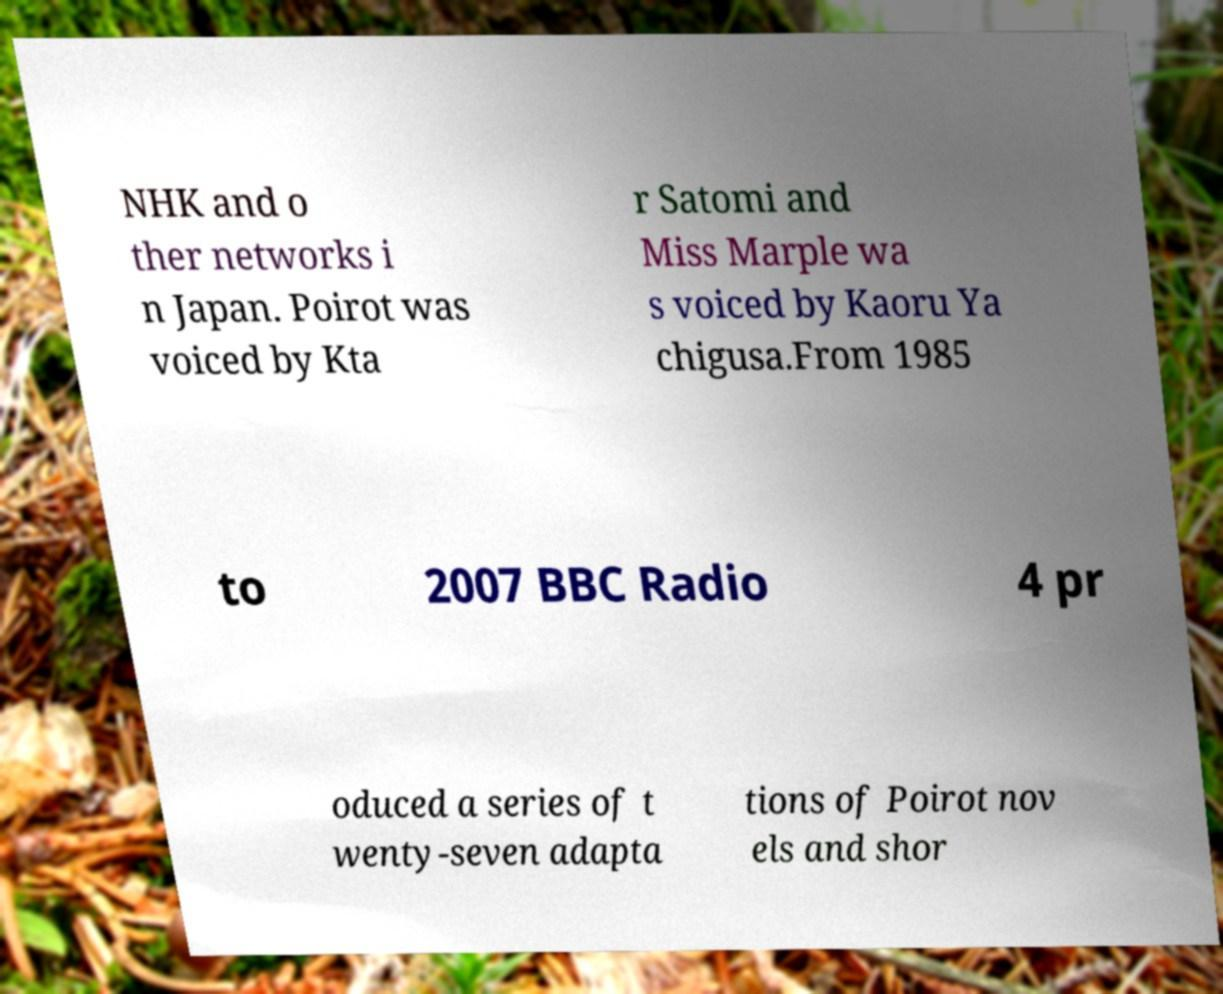There's text embedded in this image that I need extracted. Can you transcribe it verbatim? NHK and o ther networks i n Japan. Poirot was voiced by Kta r Satomi and Miss Marple wa s voiced by Kaoru Ya chigusa.From 1985 to 2007 BBC Radio 4 pr oduced a series of t wenty-seven adapta tions of Poirot nov els and shor 